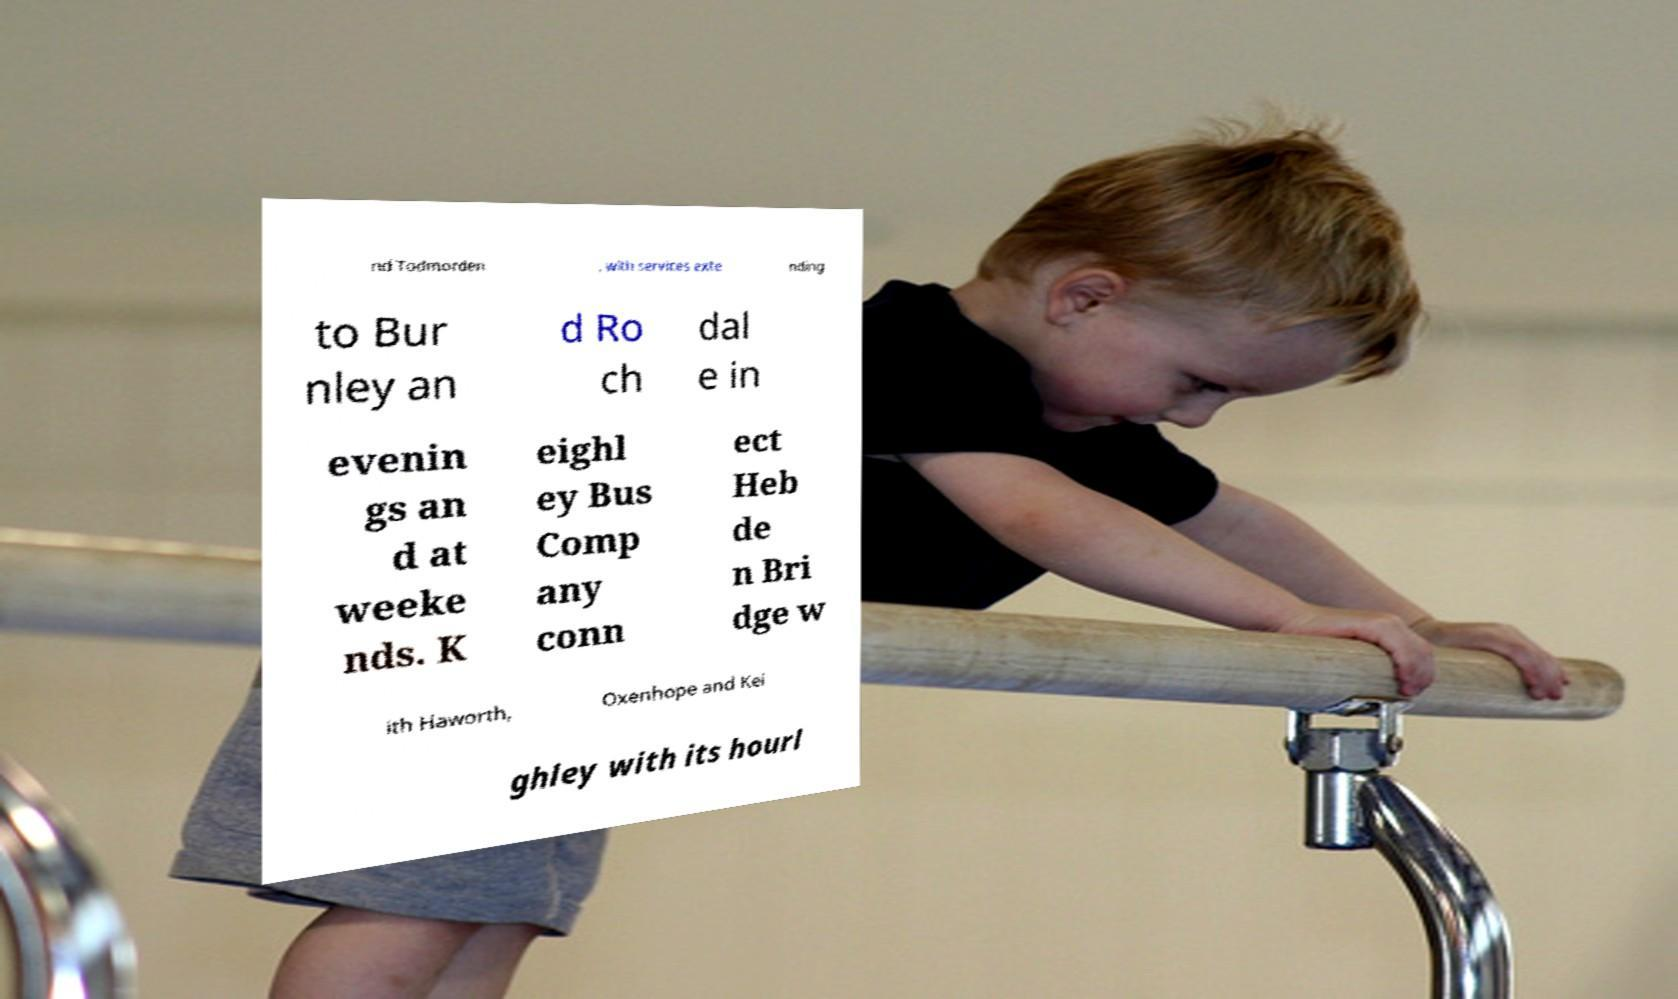Could you extract and type out the text from this image? nd Todmorden , with services exte nding to Bur nley an d Ro ch dal e in evenin gs an d at weeke nds. K eighl ey Bus Comp any conn ect Heb de n Bri dge w ith Haworth, Oxenhope and Kei ghley with its hourl 